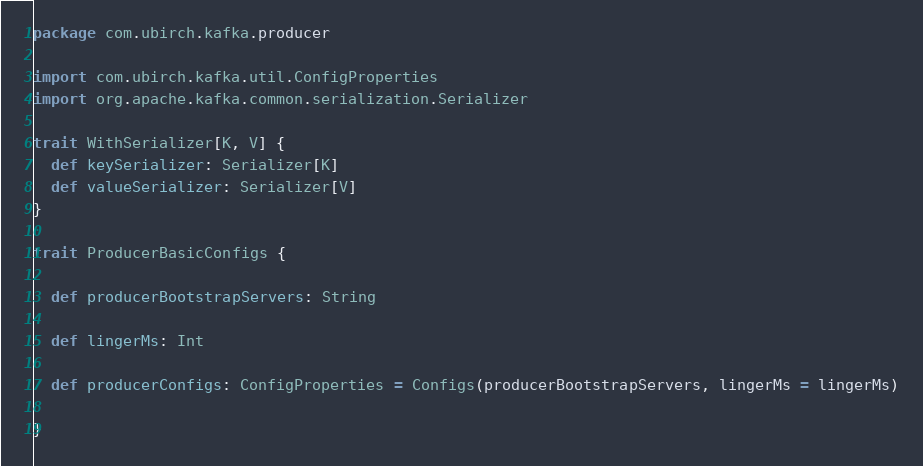<code> <loc_0><loc_0><loc_500><loc_500><_Scala_>package com.ubirch.kafka.producer

import com.ubirch.kafka.util.ConfigProperties
import org.apache.kafka.common.serialization.Serializer

trait WithSerializer[K, V] {
  def keySerializer: Serializer[K]
  def valueSerializer: Serializer[V]
}

trait ProducerBasicConfigs {

  def producerBootstrapServers: String

  def lingerMs: Int

  def producerConfigs: ConfigProperties = Configs(producerBootstrapServers, lingerMs = lingerMs)

}
</code> 